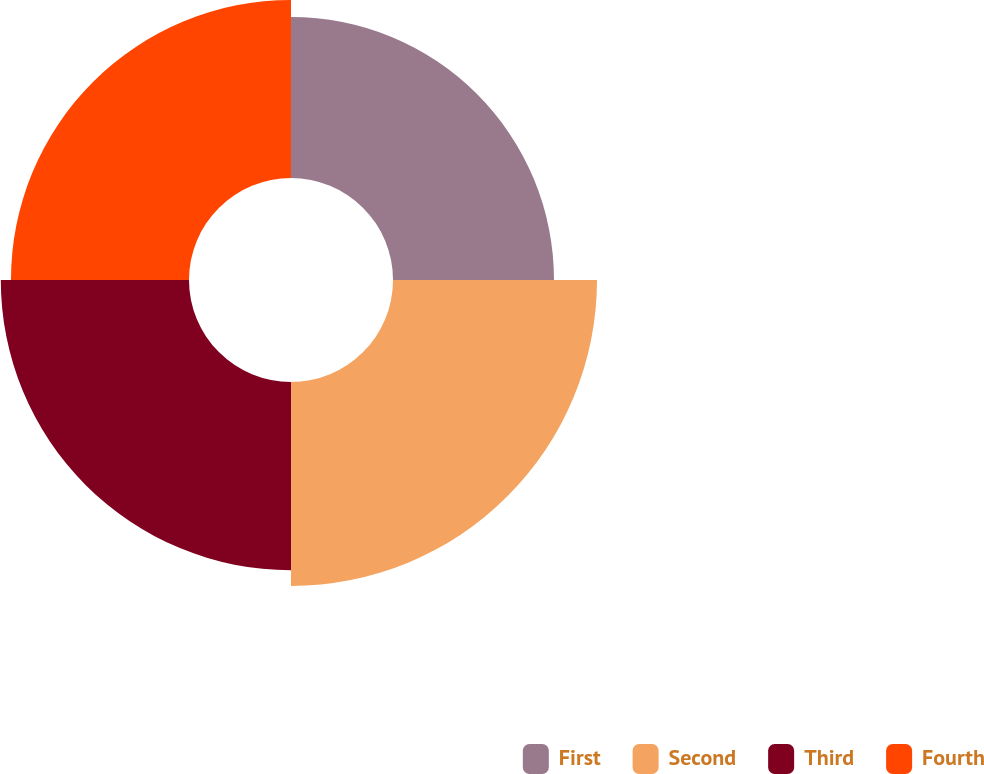Convert chart. <chart><loc_0><loc_0><loc_500><loc_500><pie_chart><fcel>First<fcel>Second<fcel>Third<fcel>Fourth<nl><fcel>22.02%<fcel>27.9%<fcel>25.74%<fcel>24.35%<nl></chart> 